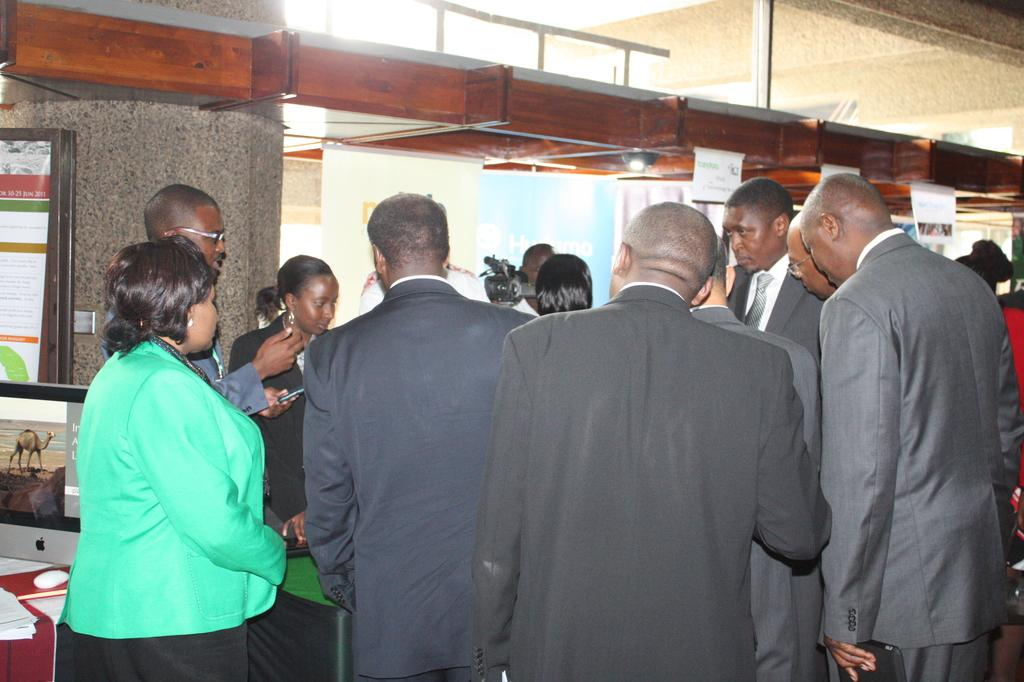How many people are in the image? There is a group of people in the image, but the exact number cannot be determined from the provided facts. What can be seen in the background of the image? There is light visible in the background of the image. What type of cable is being used by the people in the image? There is no cable present in the image. How does the image affect the viewer's mind? The image itself cannot affect the viewer's mind; it is the viewer's interpretation and reaction to the image that may have an effect on their mind. 